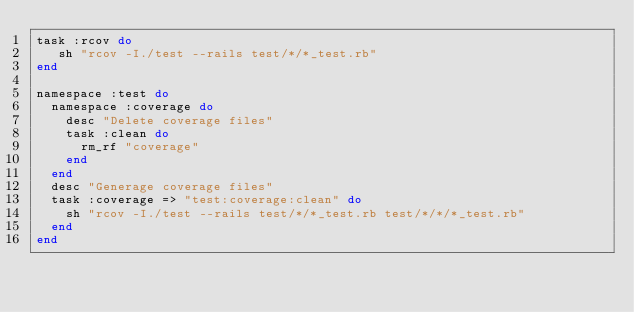<code> <loc_0><loc_0><loc_500><loc_500><_Ruby_>task :rcov do
   sh "rcov -I./test --rails test/*/*_test.rb"
end

namespace :test do
  namespace :coverage do
    desc "Delete coverage files"
    task :clean do
      rm_rf "coverage"
    end
  end
  desc "Generage coverage files"
  task :coverage => "test:coverage:clean" do
    sh "rcov -I./test --rails test/*/*_test.rb test/*/*/*_test.rb"
  end
end
</code> 